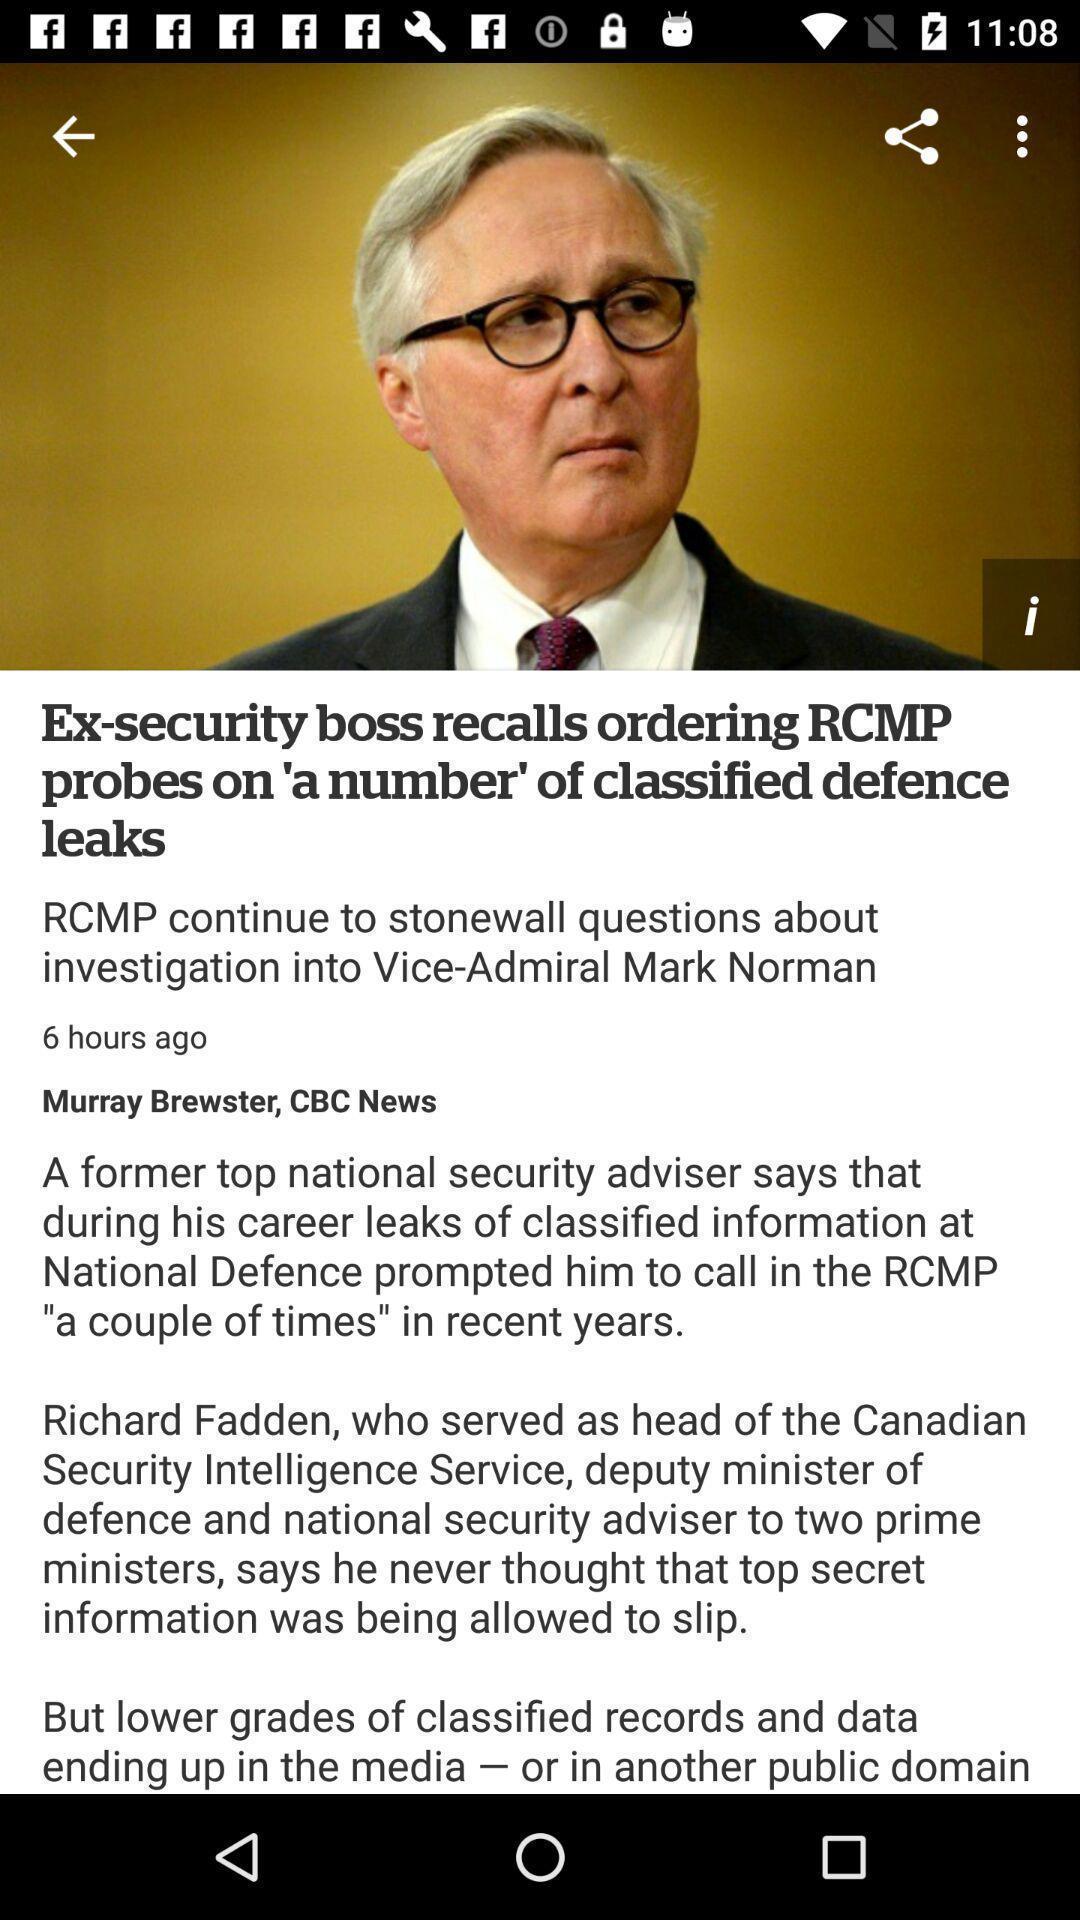Give me a narrative description of this picture. Screen shows article in a news app. 